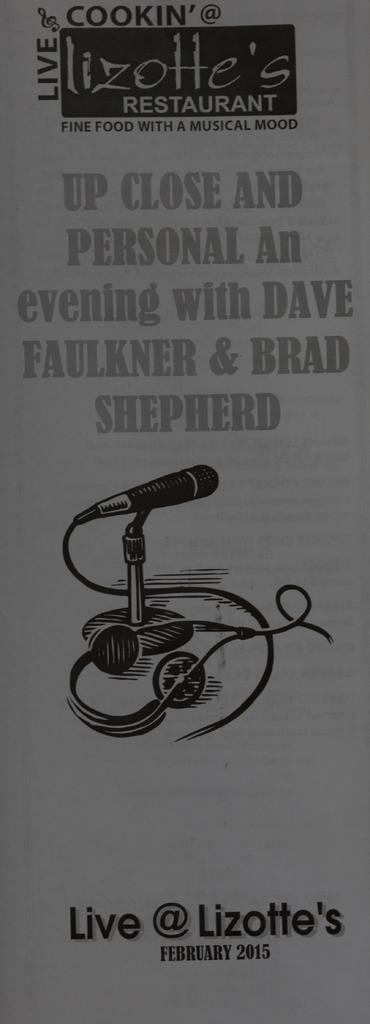What is present on the paper in the image? The paper contains a picture of a mic and a picture of a cable. Are there any other elements on the paper besides the pictures? Yes, there is writing on the paper. What type of park can be seen in the image? There is no park present in the image; it features a paper with pictures of a mic and a cable, along with writing. Can you describe the road visible in the image? There is no road present in the image; it features a paper with pictures of a mic and a cable, along with writing. 